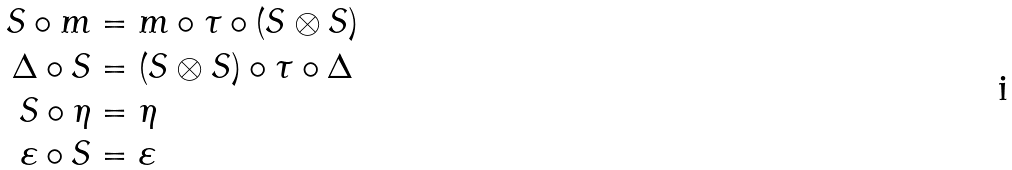Convert formula to latex. <formula><loc_0><loc_0><loc_500><loc_500>S \circ m & = m \circ \tau \circ ( S \otimes S ) \\ \Delta \circ S & = ( S \otimes S ) \circ \tau \circ \Delta \\ S \circ \eta & = \eta \\ \varepsilon \circ S & = \varepsilon</formula> 